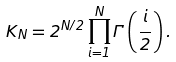<formula> <loc_0><loc_0><loc_500><loc_500>K _ { N } = 2 ^ { N / 2 } \prod _ { i = 1 } ^ { N } \Gamma \left ( \frac { i } { 2 } \right ) .</formula> 